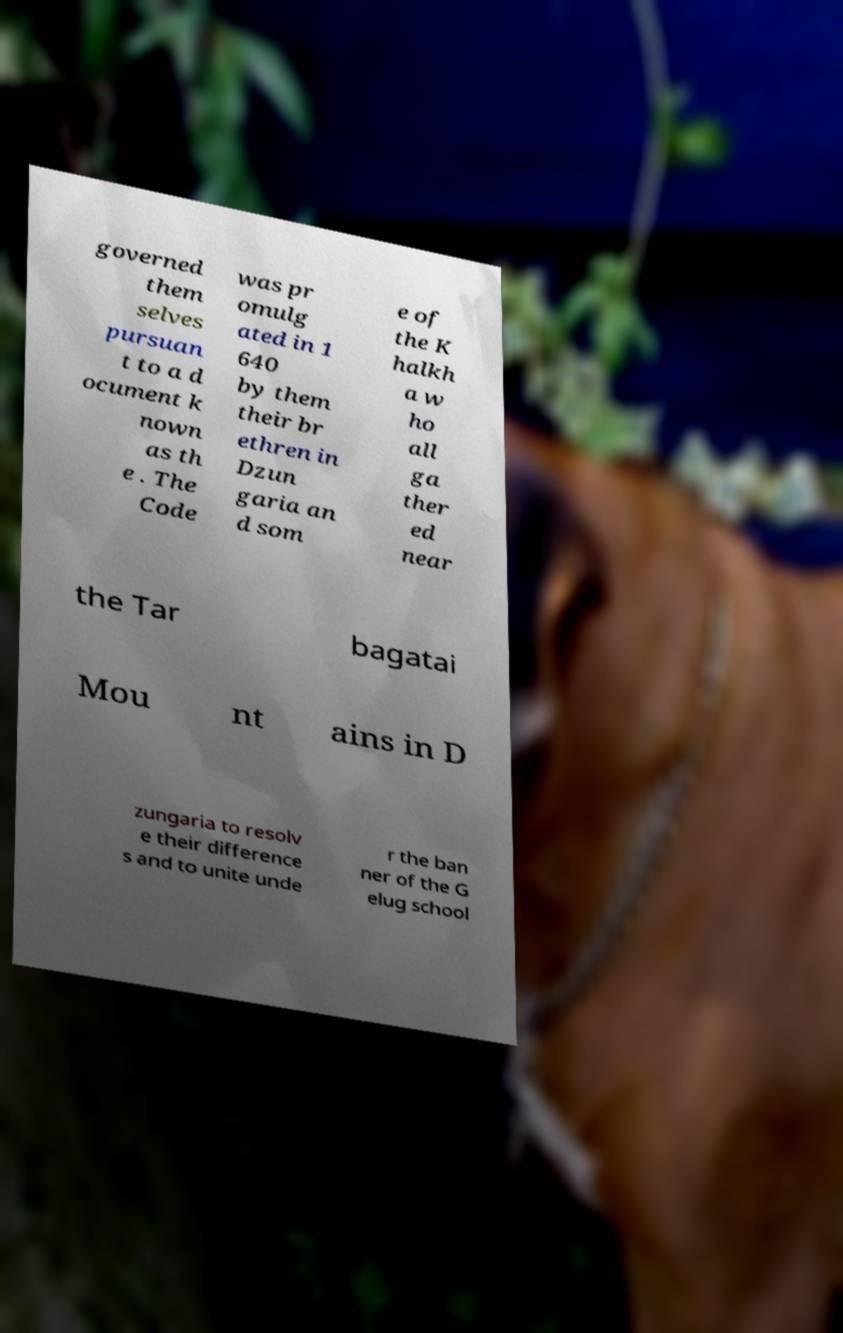Could you assist in decoding the text presented in this image and type it out clearly? governed them selves pursuan t to a d ocument k nown as th e . The Code was pr omulg ated in 1 640 by them their br ethren in Dzun garia an d som e of the K halkh a w ho all ga ther ed near the Tar bagatai Mou nt ains in D zungaria to resolv e their difference s and to unite unde r the ban ner of the G elug school 